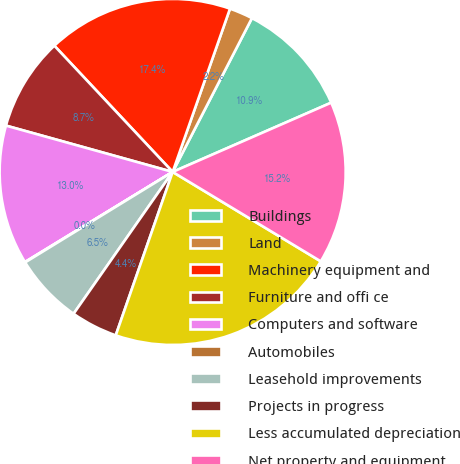Convert chart to OTSL. <chart><loc_0><loc_0><loc_500><loc_500><pie_chart><fcel>Buildings<fcel>Land<fcel>Machinery equipment and<fcel>Furniture and offi ce<fcel>Computers and software<fcel>Automobiles<fcel>Leasehold improvements<fcel>Projects in progress<fcel>Less accumulated depreciation<fcel>Net property and equipment<nl><fcel>10.87%<fcel>2.2%<fcel>17.36%<fcel>8.7%<fcel>13.03%<fcel>0.04%<fcel>6.54%<fcel>4.37%<fcel>21.69%<fcel>15.2%<nl></chart> 